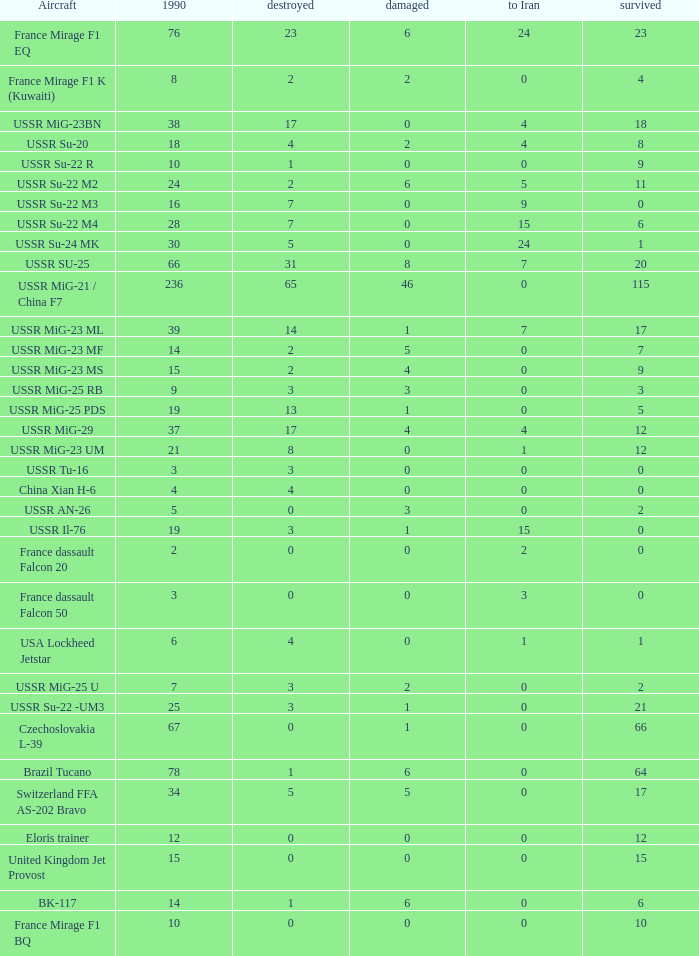If the aircraft was  ussr mig-25 rb how many were destroyed? 3.0. 